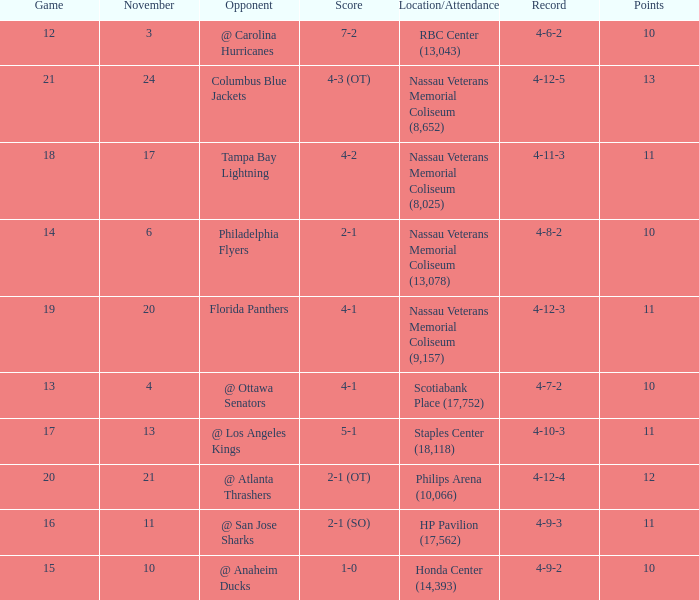What is the highest entry in November for the game 20? 21.0. 